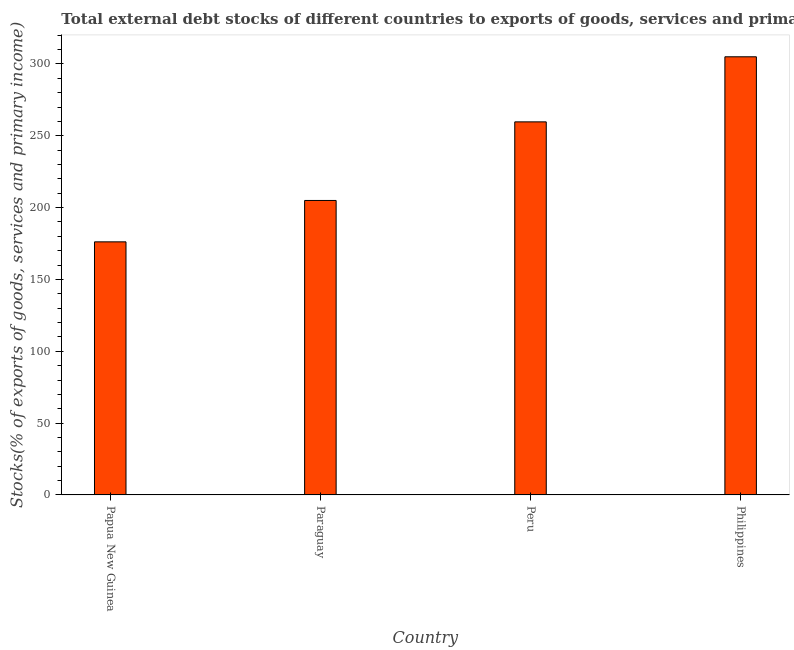Does the graph contain any zero values?
Ensure brevity in your answer.  No. Does the graph contain grids?
Make the answer very short. No. What is the title of the graph?
Provide a short and direct response. Total external debt stocks of different countries to exports of goods, services and primary income in 1982. What is the label or title of the X-axis?
Offer a terse response. Country. What is the label or title of the Y-axis?
Give a very brief answer. Stocks(% of exports of goods, services and primary income). What is the external debt stocks in Peru?
Your answer should be compact. 259.7. Across all countries, what is the maximum external debt stocks?
Provide a succinct answer. 305.01. Across all countries, what is the minimum external debt stocks?
Your answer should be compact. 176.18. In which country was the external debt stocks minimum?
Ensure brevity in your answer.  Papua New Guinea. What is the sum of the external debt stocks?
Provide a succinct answer. 945.87. What is the difference between the external debt stocks in Paraguay and Philippines?
Your response must be concise. -100.02. What is the average external debt stocks per country?
Ensure brevity in your answer.  236.47. What is the median external debt stocks?
Make the answer very short. 232.34. What is the ratio of the external debt stocks in Peru to that in Philippines?
Keep it short and to the point. 0.85. Is the external debt stocks in Peru less than that in Philippines?
Give a very brief answer. Yes. Is the difference between the external debt stocks in Peru and Philippines greater than the difference between any two countries?
Offer a very short reply. No. What is the difference between the highest and the second highest external debt stocks?
Make the answer very short. 45.3. What is the difference between the highest and the lowest external debt stocks?
Provide a short and direct response. 128.83. In how many countries, is the external debt stocks greater than the average external debt stocks taken over all countries?
Ensure brevity in your answer.  2. How many bars are there?
Offer a very short reply. 4. Are all the bars in the graph horizontal?
Keep it short and to the point. No. Are the values on the major ticks of Y-axis written in scientific E-notation?
Your answer should be very brief. No. What is the Stocks(% of exports of goods, services and primary income) in Papua New Guinea?
Provide a short and direct response. 176.18. What is the Stocks(% of exports of goods, services and primary income) in Paraguay?
Ensure brevity in your answer.  204.98. What is the Stocks(% of exports of goods, services and primary income) of Peru?
Your answer should be very brief. 259.7. What is the Stocks(% of exports of goods, services and primary income) in Philippines?
Keep it short and to the point. 305.01. What is the difference between the Stocks(% of exports of goods, services and primary income) in Papua New Guinea and Paraguay?
Ensure brevity in your answer.  -28.8. What is the difference between the Stocks(% of exports of goods, services and primary income) in Papua New Guinea and Peru?
Your answer should be very brief. -83.52. What is the difference between the Stocks(% of exports of goods, services and primary income) in Papua New Guinea and Philippines?
Your answer should be compact. -128.83. What is the difference between the Stocks(% of exports of goods, services and primary income) in Paraguay and Peru?
Give a very brief answer. -54.72. What is the difference between the Stocks(% of exports of goods, services and primary income) in Paraguay and Philippines?
Ensure brevity in your answer.  -100.02. What is the difference between the Stocks(% of exports of goods, services and primary income) in Peru and Philippines?
Provide a succinct answer. -45.3. What is the ratio of the Stocks(% of exports of goods, services and primary income) in Papua New Guinea to that in Paraguay?
Provide a short and direct response. 0.86. What is the ratio of the Stocks(% of exports of goods, services and primary income) in Papua New Guinea to that in Peru?
Provide a succinct answer. 0.68. What is the ratio of the Stocks(% of exports of goods, services and primary income) in Papua New Guinea to that in Philippines?
Keep it short and to the point. 0.58. What is the ratio of the Stocks(% of exports of goods, services and primary income) in Paraguay to that in Peru?
Provide a succinct answer. 0.79. What is the ratio of the Stocks(% of exports of goods, services and primary income) in Paraguay to that in Philippines?
Your response must be concise. 0.67. What is the ratio of the Stocks(% of exports of goods, services and primary income) in Peru to that in Philippines?
Your response must be concise. 0.85. 